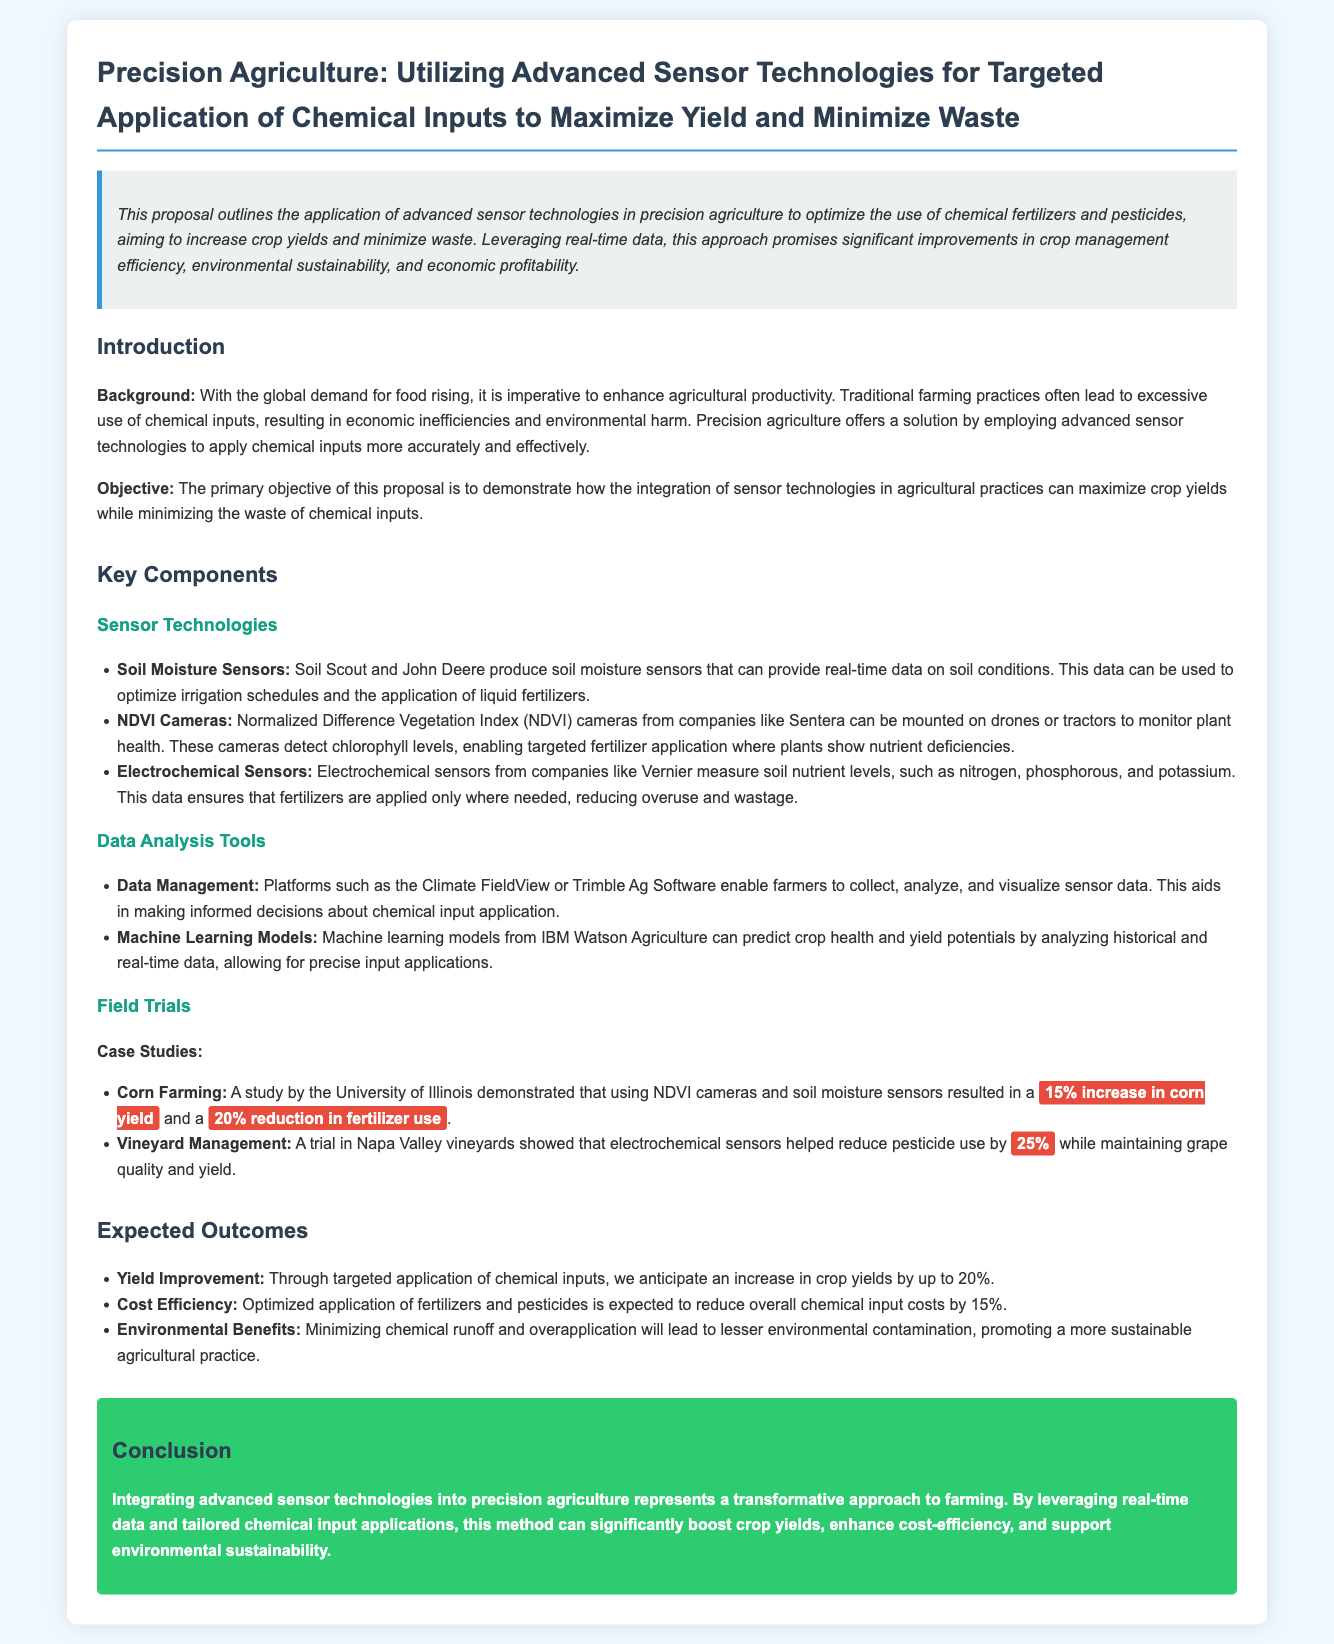What is the primary objective of this proposal? The primary objective of this proposal is to demonstrate how the integration of sensor technologies in agricultural practices can maximize crop yields while minimizing the waste of chemical inputs.
Answer: maximize crop yields while minimizing waste Which company produces soil moisture sensors? Soil moisture sensors are produced by companies like Soil Scout and John Deere.
Answer: Soil Scout and John Deere What is the expected overall reduction in chemical input costs? The document states that optimized application of fertilizers and pesticides is expected to reduce overall chemical input costs by 15%.
Answer: 15% In the corn farming case study, what was the percentage increase in corn yield? A study by the University of Illinois demonstrated that using NDVI cameras and soil moisture sensors resulted in a 15% increase in corn yield.
Answer: 15% Which data management platform is mentioned in the document? The document mentions platforms such as the Climate FieldView or Trimble Ag Software for data management.
Answer: Climate FieldView or Trimble Ag Software What outcome is anticipated through targeted applications of chemical inputs? Through targeted application of chemical inputs, an increase in crop yields by up to 20% is anticipated.
Answer: up to 20% How much did pesticide use reduce in the vineyard management trial? A trial in Napa Valley vineyards showed that electrochemical sensors helped reduce pesticide use by 25%.
Answer: 25% What is the main benefit of integrating advanced sensor technologies according to the conclusion? The conclusion states that this method can significantly boost crop yields, enhance cost-efficiency, and support environmental sustainability.
Answer: boost crop yields, enhance cost-efficiency, and support environmental sustainability 